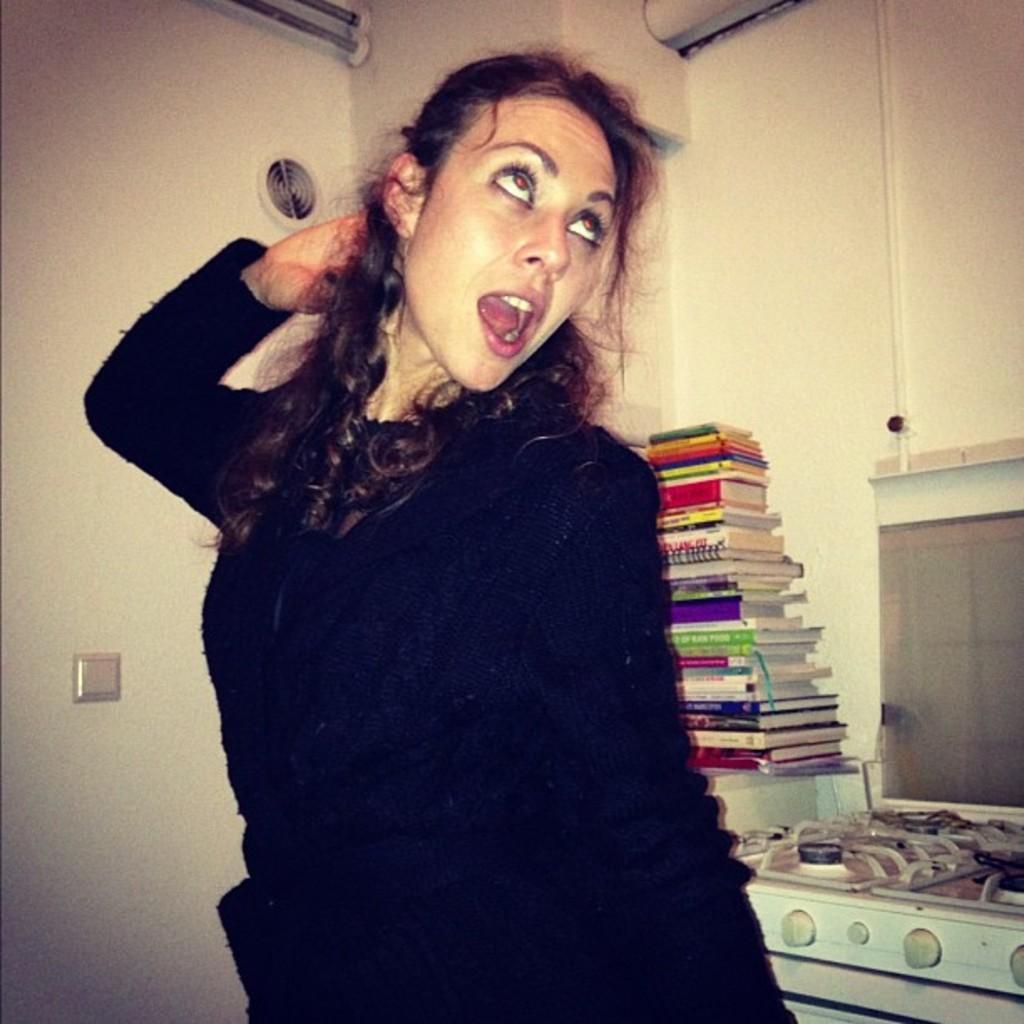How would you summarize this image in a sentence or two? In this image we can see a woman wearing black dress is here. In the background, we can see books, stove and switch board fixed to the wall. 